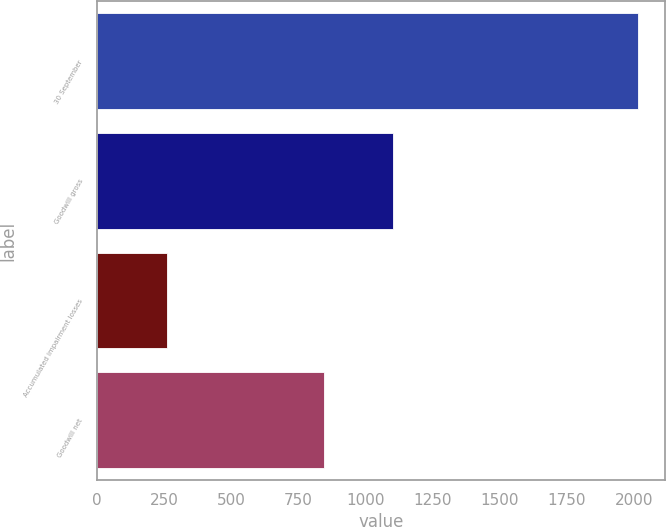Convert chart. <chart><loc_0><loc_0><loc_500><loc_500><bar_chart><fcel>30 September<fcel>Goodwill gross<fcel>Accumulated impairment losses<fcel>Goodwill net<nl><fcel>2016<fcel>1103.7<fcel>258.6<fcel>845.1<nl></chart> 